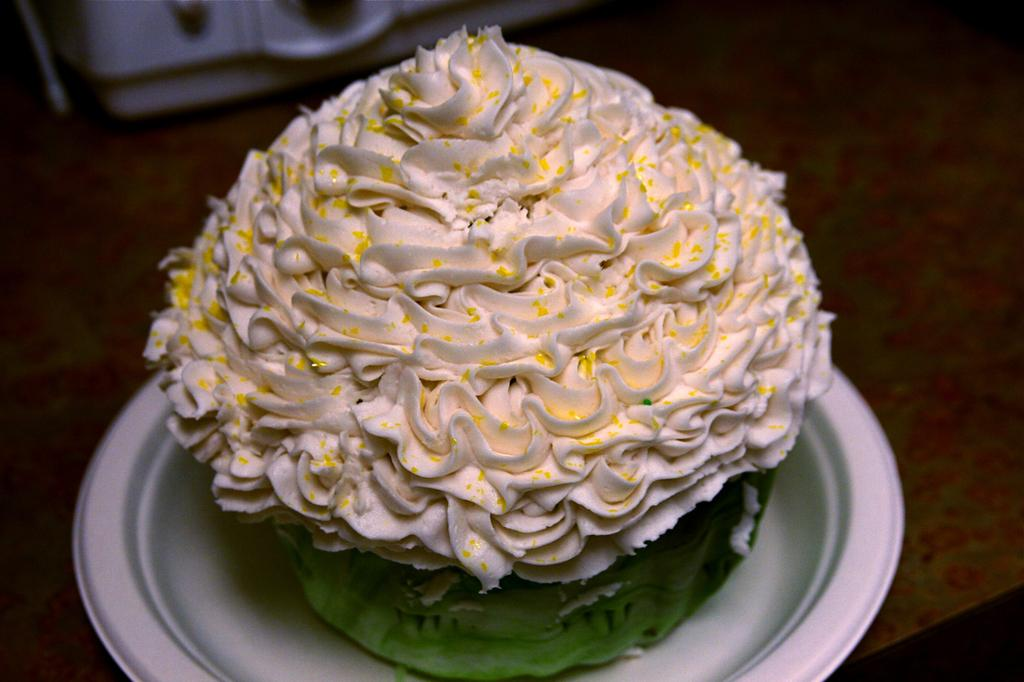What is the main subject on the plate in the image? There is a dessert on a plate in the image. Can you describe any other objects on the table in the image? There is another object on the table in the image. How many eggs are being used in the dessert preparation in the image? There is no mention of eggs or any dessert preparation in the image; it only shows a dessert on a plate and another object on the table. Can you describe the type of feather used as a decoration in the dessert? There is no feather or any decoration mentioned in the image; it only shows a dessert on a plate and another object on the table. 